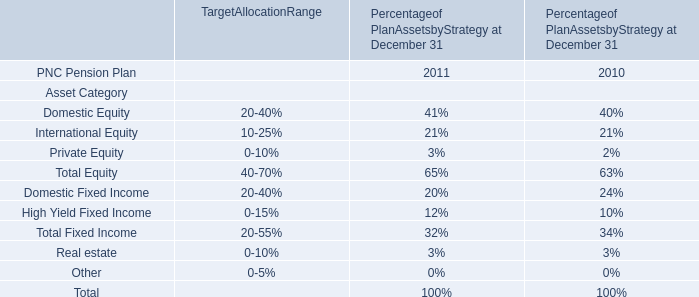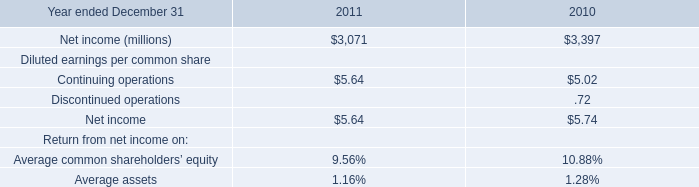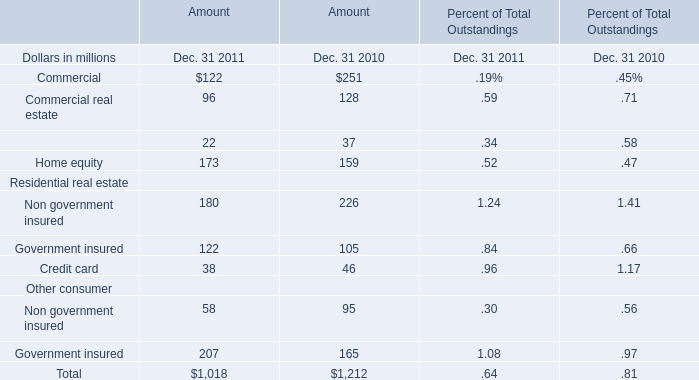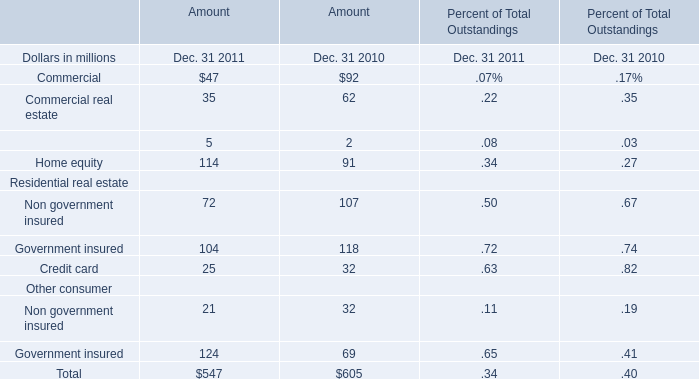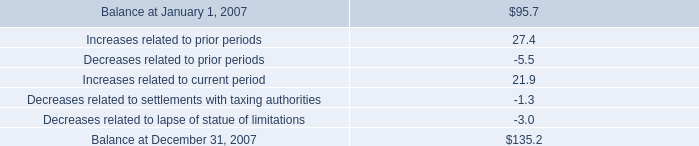what percent of the 2007 balance increase is from prior periods? 
Computations: (27.4 / (135.2 - 95.7))
Answer: 0.69367. 